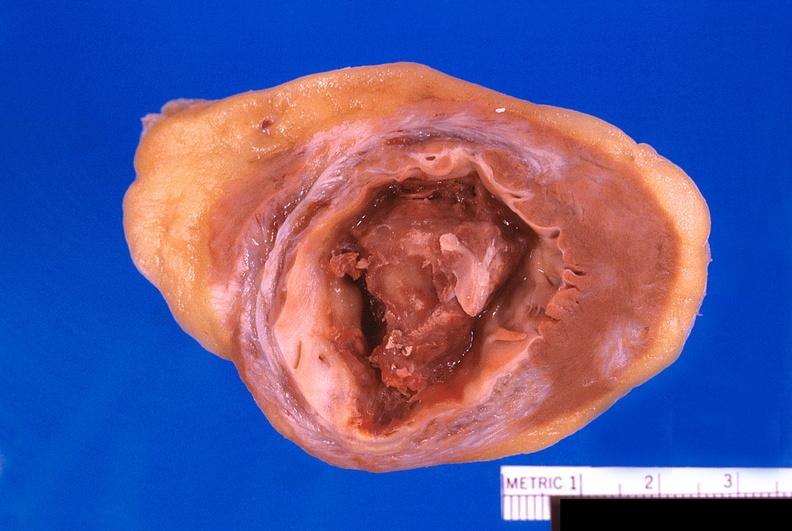s case of peritonitis slide present?
Answer the question using a single word or phrase. No 